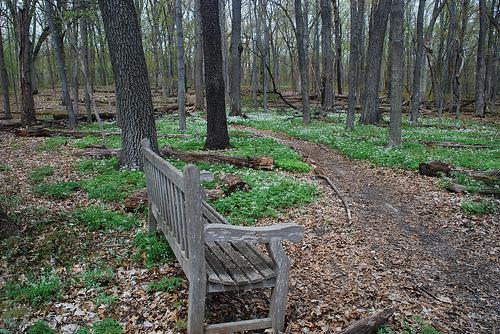Question: when was this pic taken?
Choices:
A. During the day.
B. Morning.
C. Noon.
D. Dusk.
Answer with the letter. Answer: A Question: where are the dead leaves?
Choices:
A. Scattered on the ground.
B. In a pile.
C. Next to the rake.
D. Under the tree.
Answer with the letter. Answer: A Question: what is in the background?
Choices:
A. Mountains.
B. A forest.
C. Oceans.
D. Fields.
Answer with the letter. Answer: B 